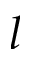<formula> <loc_0><loc_0><loc_500><loc_500>l</formula> 